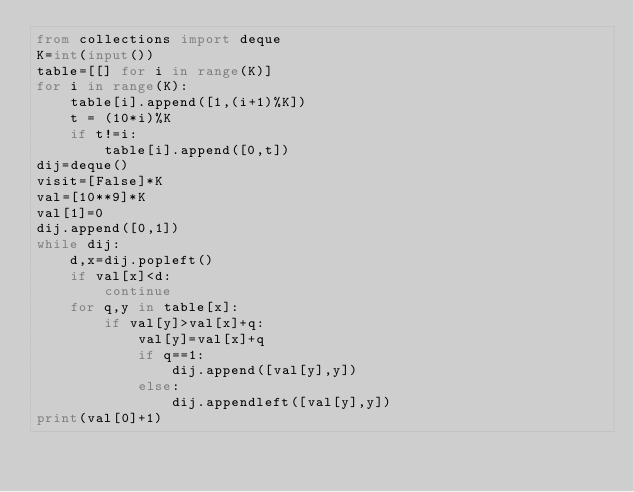<code> <loc_0><loc_0><loc_500><loc_500><_Python_>from collections import deque
K=int(input())
table=[[] for i in range(K)]
for i in range(K):
    table[i].append([1,(i+1)%K])
    t = (10*i)%K
    if t!=i:
        table[i].append([0,t])
dij=deque()
visit=[False]*K
val=[10**9]*K
val[1]=0
dij.append([0,1])
while dij:
    d,x=dij.popleft()
    if val[x]<d:
        continue
    for q,y in table[x]:
        if val[y]>val[x]+q:
            val[y]=val[x]+q
            if q==1:
                dij.append([val[y],y])
            else:
                dij.appendleft([val[y],y])
print(val[0]+1)</code> 